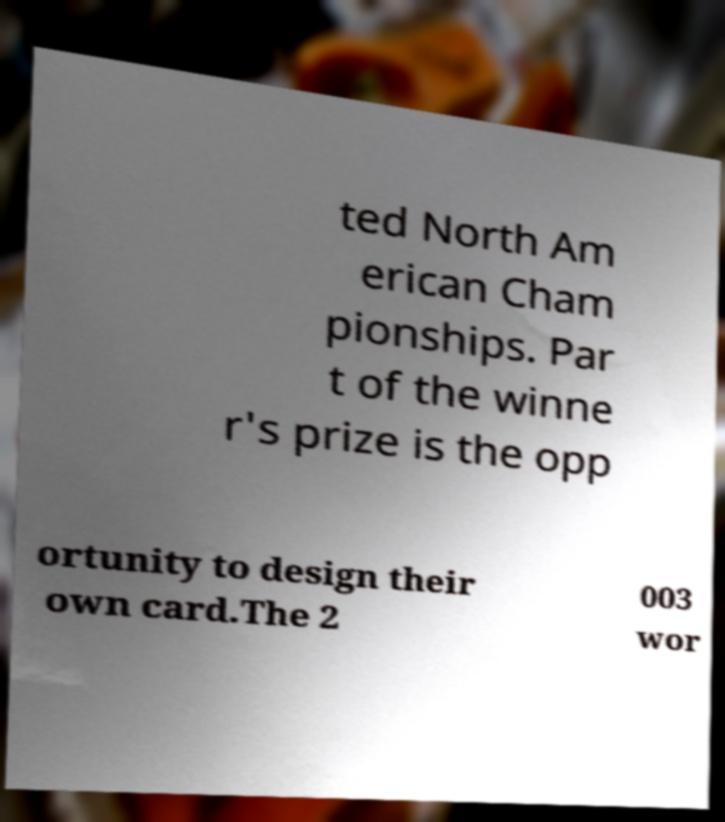Could you extract and type out the text from this image? ted North Am erican Cham pionships. Par t of the winne r's prize is the opp ortunity to design their own card.The 2 003 wor 